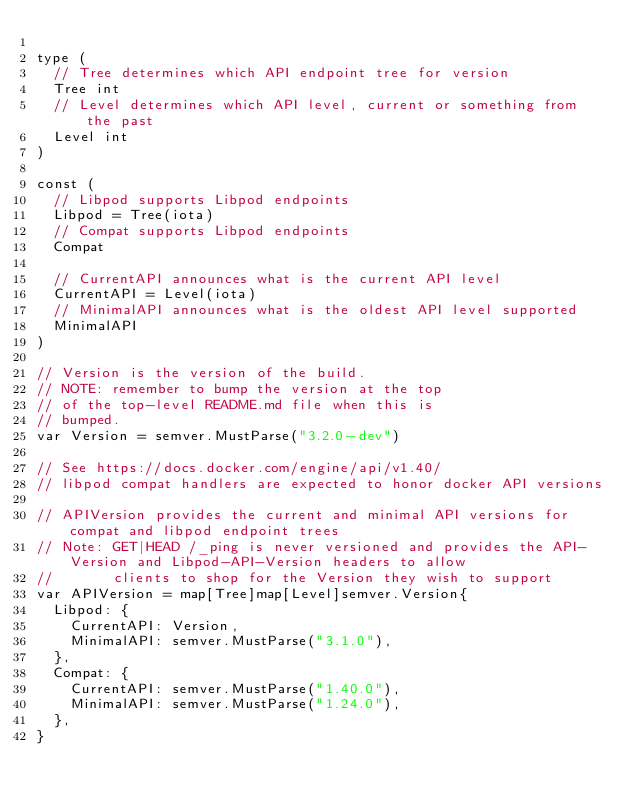<code> <loc_0><loc_0><loc_500><loc_500><_Go_>
type (
	// Tree determines which API endpoint tree for version
	Tree int
	// Level determines which API level, current or something from the past
	Level int
)

const (
	// Libpod supports Libpod endpoints
	Libpod = Tree(iota)
	// Compat supports Libpod endpoints
	Compat

	// CurrentAPI announces what is the current API level
	CurrentAPI = Level(iota)
	// MinimalAPI announces what is the oldest API level supported
	MinimalAPI
)

// Version is the version of the build.
// NOTE: remember to bump the version at the top
// of the top-level README.md file when this is
// bumped.
var Version = semver.MustParse("3.2.0-dev")

// See https://docs.docker.com/engine/api/v1.40/
// libpod compat handlers are expected to honor docker API versions

// APIVersion provides the current and minimal API versions for compat and libpod endpoint trees
// Note: GET|HEAD /_ping is never versioned and provides the API-Version and Libpod-API-Version headers to allow
//       clients to shop for the Version they wish to support
var APIVersion = map[Tree]map[Level]semver.Version{
	Libpod: {
		CurrentAPI: Version,
		MinimalAPI: semver.MustParse("3.1.0"),
	},
	Compat: {
		CurrentAPI: semver.MustParse("1.40.0"),
		MinimalAPI: semver.MustParse("1.24.0"),
	},
}
</code> 